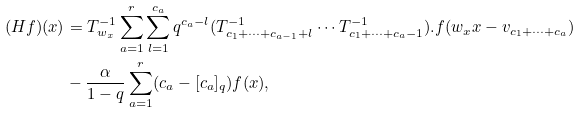Convert formula to latex. <formula><loc_0><loc_0><loc_500><loc_500>( H f ) ( x ) & = T _ { w _ { x } } ^ { - 1 } \sum _ { a = 1 } ^ { r } \sum _ { l = 1 } ^ { c _ { a } } q ^ { c _ { a } - l } ( T _ { c _ { 1 } + \cdots + c _ { a - 1 } + l } ^ { - 1 } \cdots T _ { c _ { 1 } + \cdots + c _ { a } - 1 } ^ { - 1 } ) . f ( w _ { x } x - v _ { c _ { 1 } + \cdots + c _ { a } } ) \\ & - \frac { \alpha } { 1 - q } \sum _ { a = 1 } ^ { r } ( c _ { a } - [ c _ { a } ] _ { q } ) f ( x ) ,</formula> 